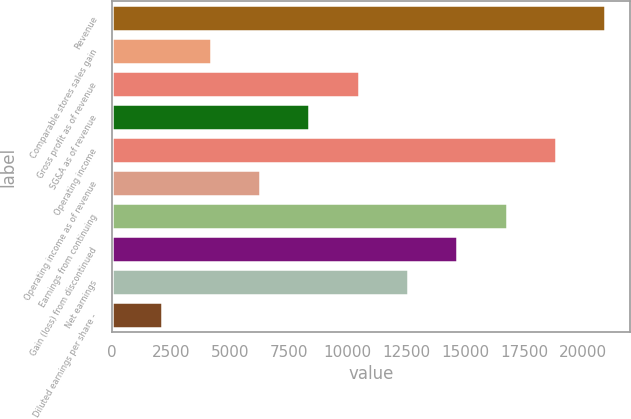Convert chart to OTSL. <chart><loc_0><loc_0><loc_500><loc_500><bar_chart><fcel>Revenue<fcel>Comparable stores sales gain<fcel>Gross profit as of revenue<fcel>SG&A as of revenue<fcel>Operating income<fcel>Operating income as of revenue<fcel>Earnings from continuing<fcel>Gain (loss) from discontinued<fcel>Net earnings<fcel>Diluted earnings per share -<nl><fcel>20943<fcel>4188.85<fcel>10471.7<fcel>8377.39<fcel>18848.7<fcel>6283.12<fcel>16754.5<fcel>14660.2<fcel>12565.9<fcel>2094.58<nl></chart> 